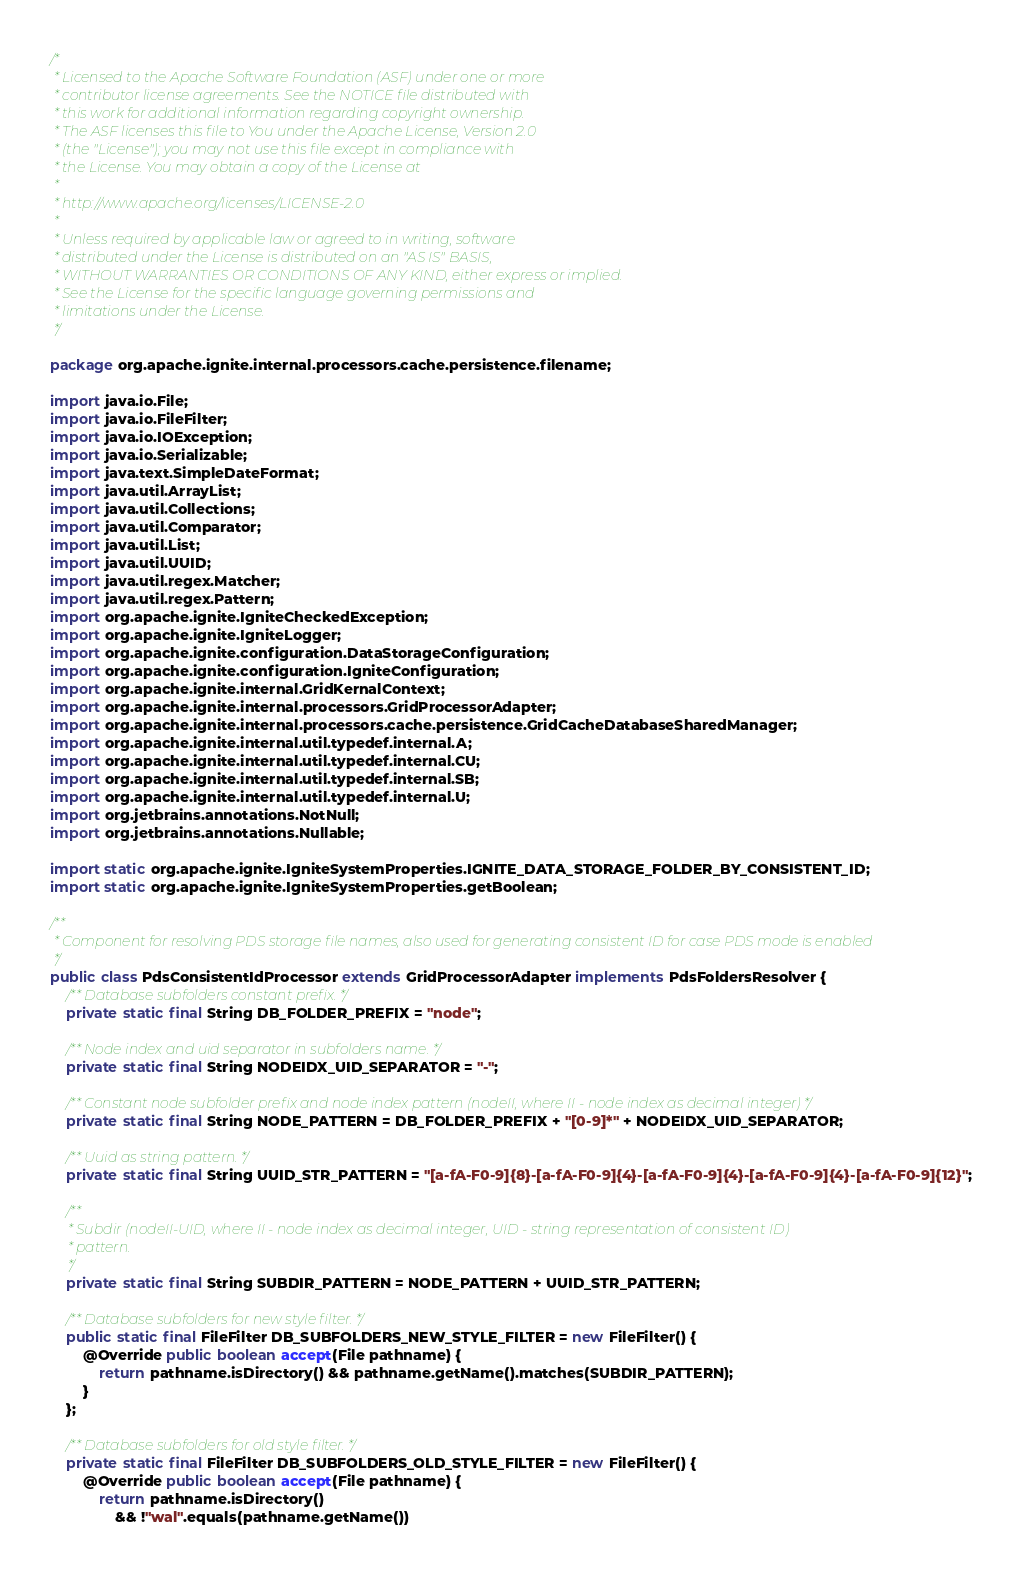Convert code to text. <code><loc_0><loc_0><loc_500><loc_500><_Java_>/*
 * Licensed to the Apache Software Foundation (ASF) under one or more
 * contributor license agreements. See the NOTICE file distributed with
 * this work for additional information regarding copyright ownership.
 * The ASF licenses this file to You under the Apache License, Version 2.0
 * (the "License"); you may not use this file except in compliance with
 * the License. You may obtain a copy of the License at
 *
 * http://www.apache.org/licenses/LICENSE-2.0
 *
 * Unless required by applicable law or agreed to in writing, software
 * distributed under the License is distributed on an "AS IS" BASIS,
 * WITHOUT WARRANTIES OR CONDITIONS OF ANY KIND, either express or implied.
 * See the License for the specific language governing permissions and
 * limitations under the License.
 */

package org.apache.ignite.internal.processors.cache.persistence.filename;

import java.io.File;
import java.io.FileFilter;
import java.io.IOException;
import java.io.Serializable;
import java.text.SimpleDateFormat;
import java.util.ArrayList;
import java.util.Collections;
import java.util.Comparator;
import java.util.List;
import java.util.UUID;
import java.util.regex.Matcher;
import java.util.regex.Pattern;
import org.apache.ignite.IgniteCheckedException;
import org.apache.ignite.IgniteLogger;
import org.apache.ignite.configuration.DataStorageConfiguration;
import org.apache.ignite.configuration.IgniteConfiguration;
import org.apache.ignite.internal.GridKernalContext;
import org.apache.ignite.internal.processors.GridProcessorAdapter;
import org.apache.ignite.internal.processors.cache.persistence.GridCacheDatabaseSharedManager;
import org.apache.ignite.internal.util.typedef.internal.A;
import org.apache.ignite.internal.util.typedef.internal.CU;
import org.apache.ignite.internal.util.typedef.internal.SB;
import org.apache.ignite.internal.util.typedef.internal.U;
import org.jetbrains.annotations.NotNull;
import org.jetbrains.annotations.Nullable;

import static org.apache.ignite.IgniteSystemProperties.IGNITE_DATA_STORAGE_FOLDER_BY_CONSISTENT_ID;
import static org.apache.ignite.IgniteSystemProperties.getBoolean;

/**
 * Component for resolving PDS storage file names, also used for generating consistent ID for case PDS mode is enabled
 */
public class PdsConsistentIdProcessor extends GridProcessorAdapter implements PdsFoldersResolver {
    /** Database subfolders constant prefix. */
    private static final String DB_FOLDER_PREFIX = "node";

    /** Node index and uid separator in subfolders name. */
    private static final String NODEIDX_UID_SEPARATOR = "-";

    /** Constant node subfolder prefix and node index pattern (nodeII, where II - node index as decimal integer) */
    private static final String NODE_PATTERN = DB_FOLDER_PREFIX + "[0-9]*" + NODEIDX_UID_SEPARATOR;

    /** Uuid as string pattern. */
    private static final String UUID_STR_PATTERN = "[a-fA-F0-9]{8}-[a-fA-F0-9]{4}-[a-fA-F0-9]{4}-[a-fA-F0-9]{4}-[a-fA-F0-9]{12}";

    /**
     * Subdir (nodeII-UID, where II - node index as decimal integer, UID - string representation of consistent ID)
     * pattern.
     */
    private static final String SUBDIR_PATTERN = NODE_PATTERN + UUID_STR_PATTERN;

    /** Database subfolders for new style filter. */
    public static final FileFilter DB_SUBFOLDERS_NEW_STYLE_FILTER = new FileFilter() {
        @Override public boolean accept(File pathname) {
            return pathname.isDirectory() && pathname.getName().matches(SUBDIR_PATTERN);
        }
    };

    /** Database subfolders for old style filter. */
    private static final FileFilter DB_SUBFOLDERS_OLD_STYLE_FILTER = new FileFilter() {
        @Override public boolean accept(File pathname) {
            return pathname.isDirectory()
                && !"wal".equals(pathname.getName())</code> 